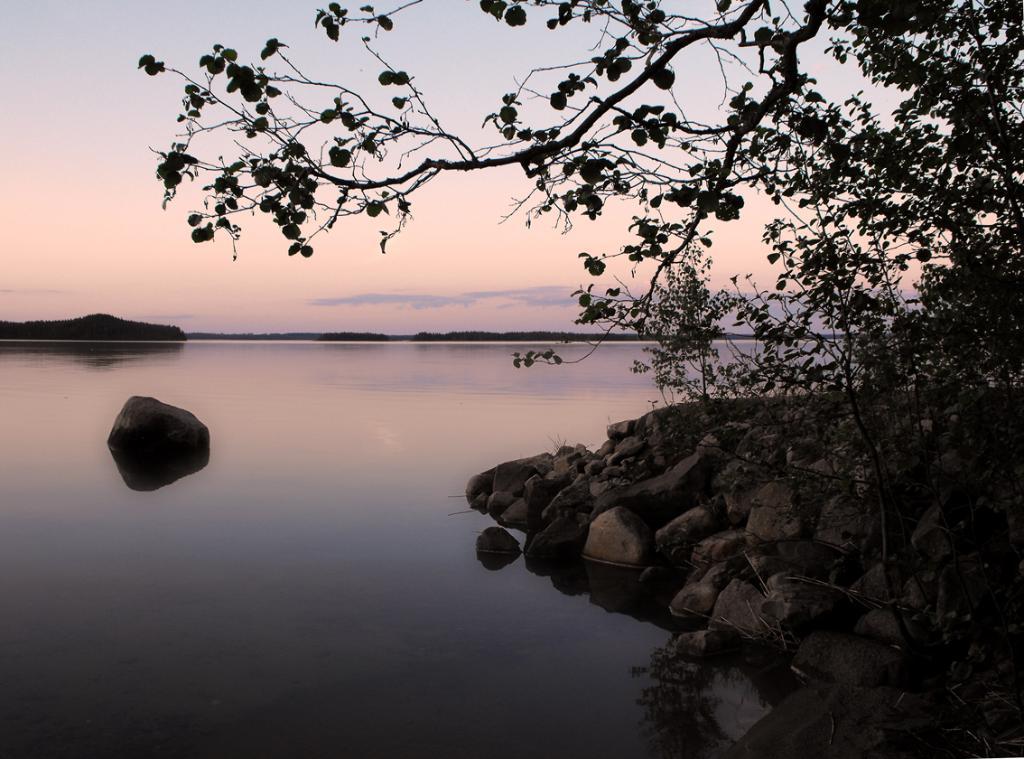Describe this image in one or two sentences. In this image on the right side, I can see the stones and the trees. In the background, I can see the water and clouds in the sky. 